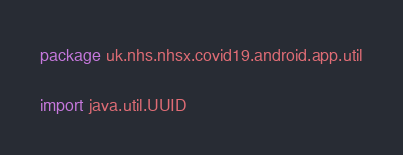<code> <loc_0><loc_0><loc_500><loc_500><_Kotlin_>package uk.nhs.nhsx.covid19.android.app.util

import java.util.UUID
</code> 